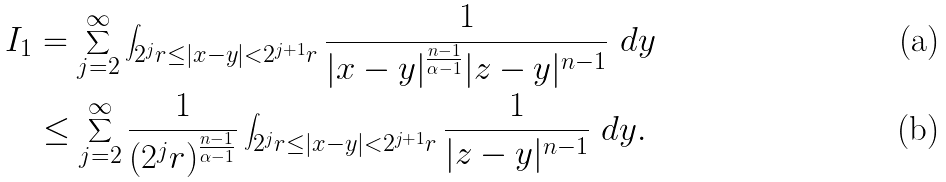Convert formula to latex. <formula><loc_0><loc_0><loc_500><loc_500>I _ { 1 } & = \sum _ { j = 2 } ^ { \infty } \int _ { 2 ^ { j } r \leq | x - y | < 2 ^ { j + 1 } r } \frac { 1 } { | x - y | ^ { \frac { n - 1 } { \alpha - 1 } } | z - y | ^ { n - 1 } } \ d y \\ & \leq \sum _ { j = 2 } ^ { \infty } \frac { 1 } { ( 2 ^ { j } r ) ^ { \frac { n - 1 } { \alpha - 1 } } } \int _ { 2 ^ { j } r \leq | x - y | < 2 ^ { j + 1 } r } \frac { 1 } { | z - y | ^ { n - 1 } } \ d y .</formula> 